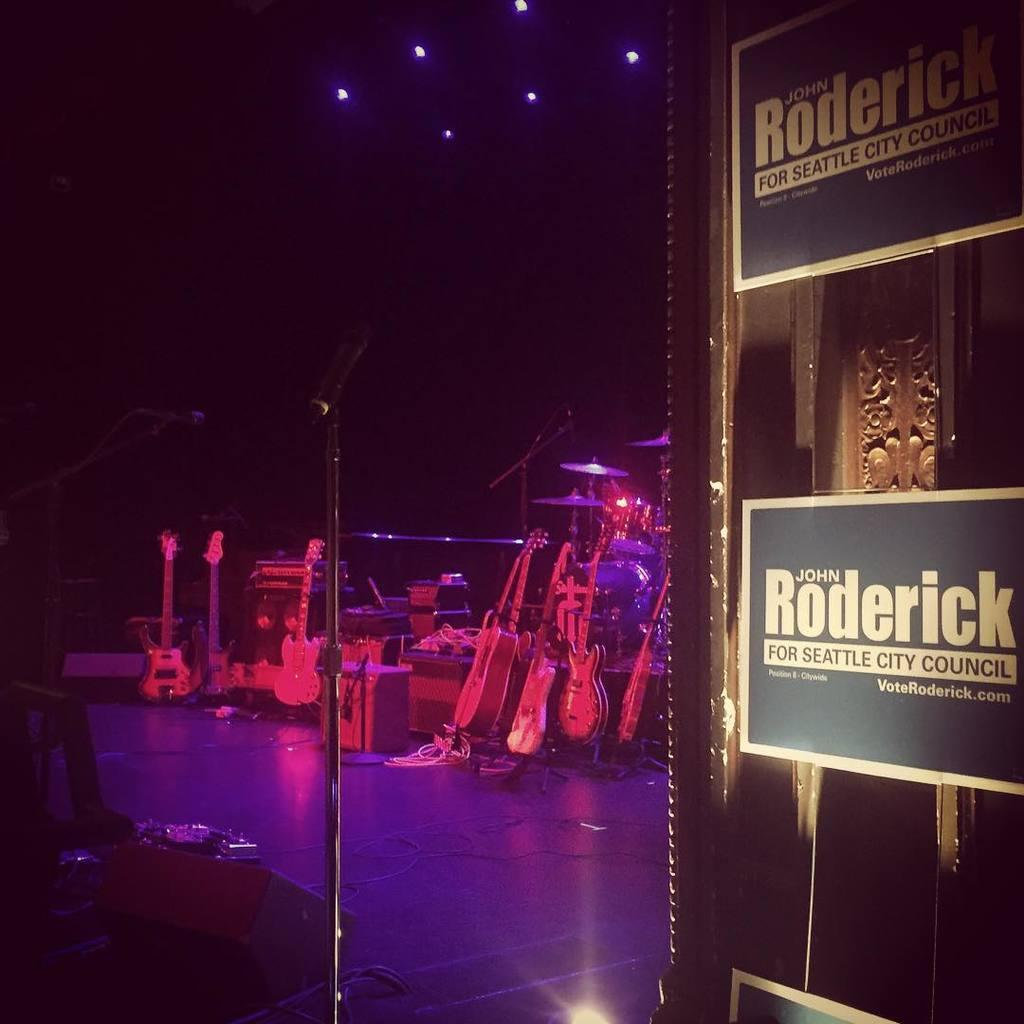What type of equipment is visible in the image? There are microphones, guitars, and other musical instruments in the image. Are there any wires present in the image? Yes, there are wires in the image. What can be seen on top in the image? There are lights on top in the image. What other objects can be found in the image besides musical instruments? There are other objects in the image, but their specific nature is not mentioned in the provided facts. What is the daughter doing in the image? There is no mention of a daughter or any person in the image; it only describes equipment and objects. 